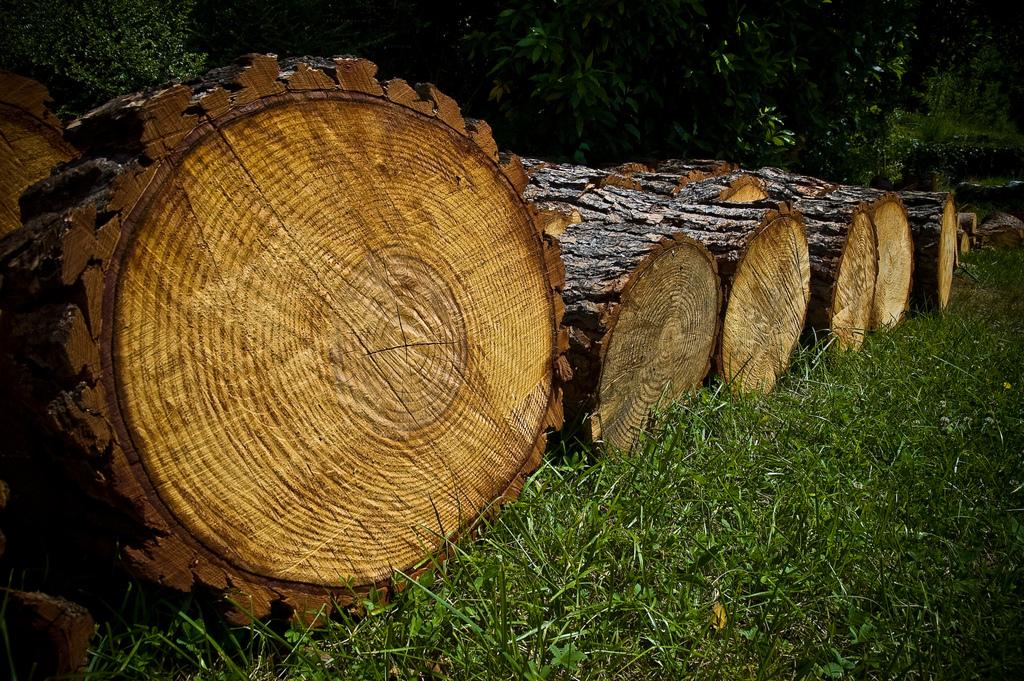What is on the grassy land in the image? There are bark pieces on the grassy land. What can be seen in the background of the image? Trees are present in the background. What type of tub is visible in the image? There is no tub present in the image. 